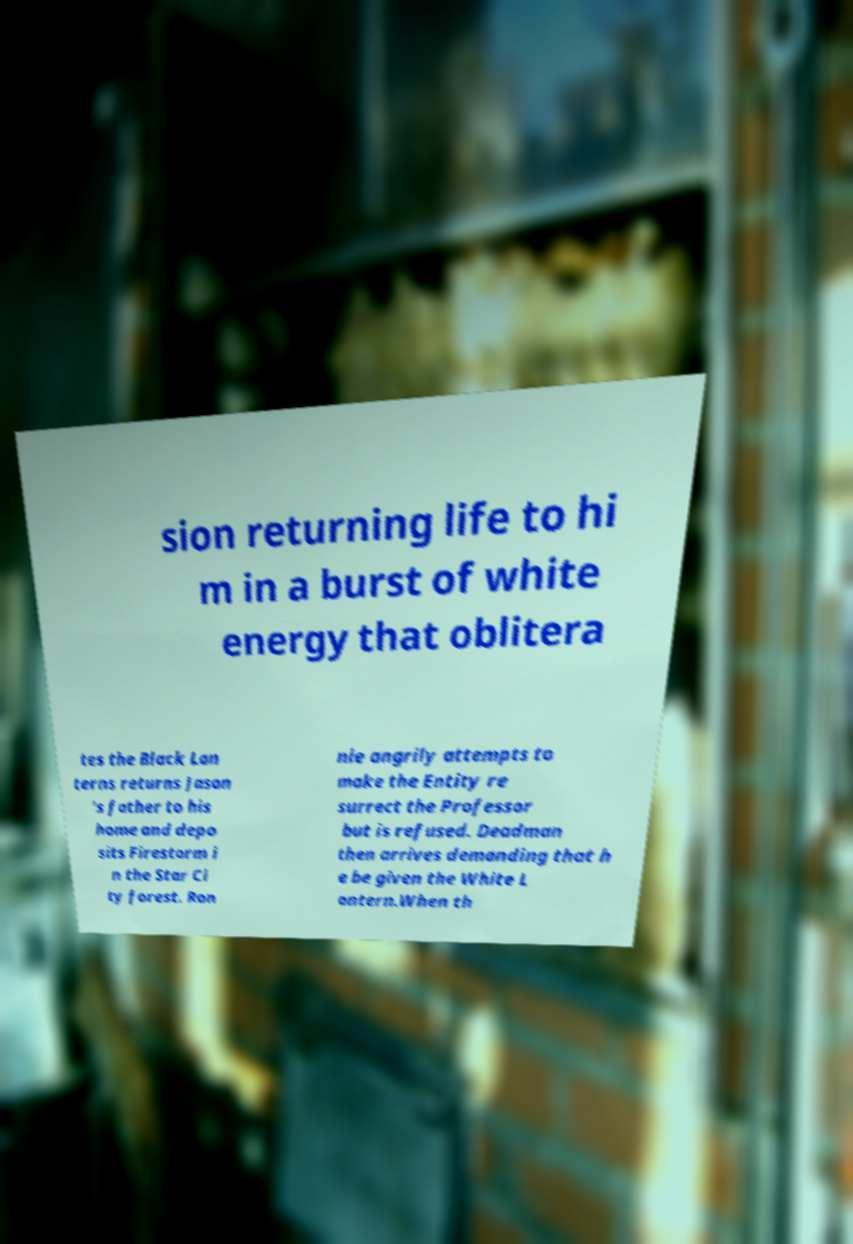Could you extract and type out the text from this image? sion returning life to hi m in a burst of white energy that oblitera tes the Black Lan terns returns Jason 's father to his home and depo sits Firestorm i n the Star Ci ty forest. Ron nie angrily attempts to make the Entity re surrect the Professor but is refused. Deadman then arrives demanding that h e be given the White L antern.When th 